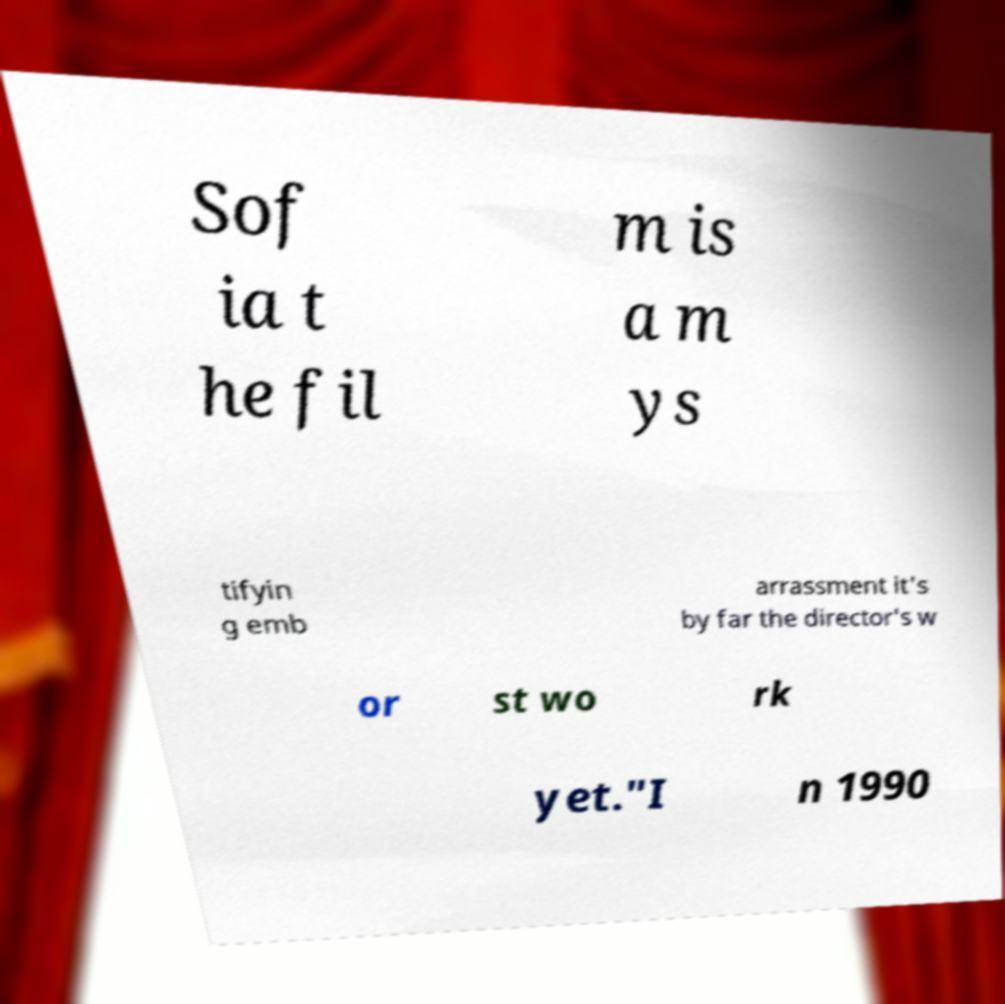Could you assist in decoding the text presented in this image and type it out clearly? Sof ia t he fil m is a m ys tifyin g emb arrassment it's by far the director's w or st wo rk yet."I n 1990 